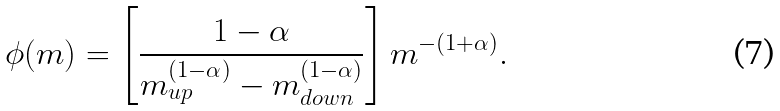Convert formula to latex. <formula><loc_0><loc_0><loc_500><loc_500>\phi ( m ) = \left [ \frac { 1 - \alpha } { m _ { u p } ^ { ( 1 - \alpha ) } - m _ { d o w n } ^ { ( 1 - \alpha ) } } \right ] m ^ { - ( 1 + \alpha ) } .</formula> 